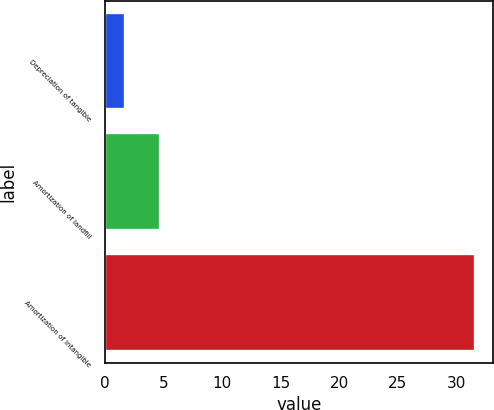<chart> <loc_0><loc_0><loc_500><loc_500><bar_chart><fcel>Depreciation of tangible<fcel>Amortization of landfill<fcel>Amortization of intangible<nl><fcel>1.7<fcel>4.69<fcel>31.6<nl></chart> 